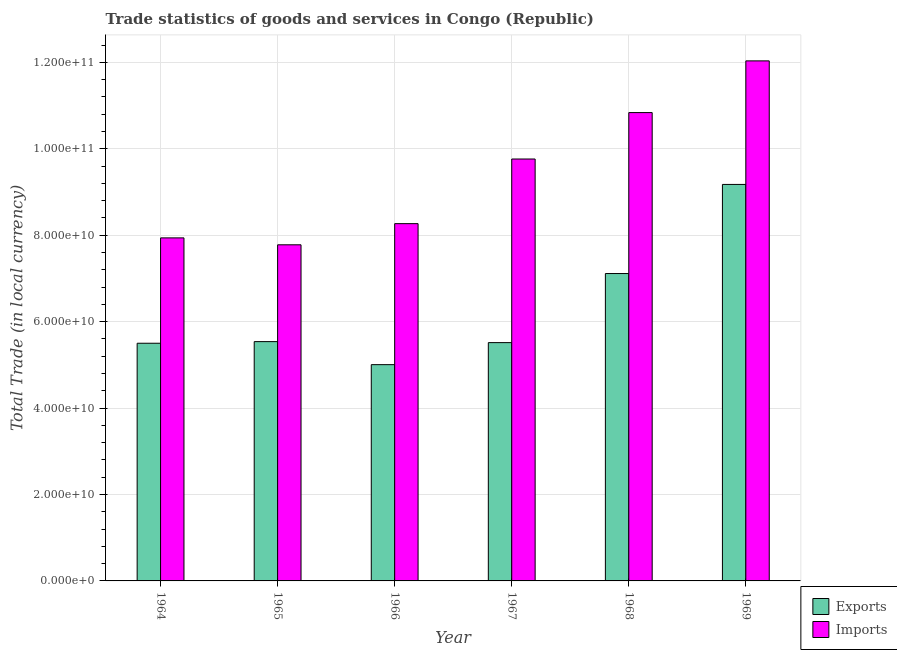How many different coloured bars are there?
Your answer should be compact. 2. Are the number of bars per tick equal to the number of legend labels?
Give a very brief answer. Yes. How many bars are there on the 5th tick from the left?
Your answer should be very brief. 2. What is the label of the 3rd group of bars from the left?
Your response must be concise. 1966. What is the export of goods and services in 1966?
Your answer should be very brief. 5.00e+1. Across all years, what is the maximum export of goods and services?
Your response must be concise. 9.18e+1. Across all years, what is the minimum export of goods and services?
Give a very brief answer. 5.00e+1. In which year was the imports of goods and services maximum?
Your response must be concise. 1969. In which year was the imports of goods and services minimum?
Offer a terse response. 1965. What is the total export of goods and services in the graph?
Keep it short and to the point. 3.78e+11. What is the difference between the imports of goods and services in 1964 and that in 1968?
Provide a succinct answer. -2.90e+1. What is the difference between the export of goods and services in 1966 and the imports of goods and services in 1965?
Keep it short and to the point. -5.33e+09. What is the average imports of goods and services per year?
Offer a terse response. 9.44e+1. In the year 1965, what is the difference between the imports of goods and services and export of goods and services?
Offer a very short reply. 0. What is the ratio of the imports of goods and services in 1966 to that in 1969?
Give a very brief answer. 0.69. Is the difference between the imports of goods and services in 1965 and 1967 greater than the difference between the export of goods and services in 1965 and 1967?
Make the answer very short. No. What is the difference between the highest and the second highest export of goods and services?
Offer a terse response. 2.06e+1. What is the difference between the highest and the lowest export of goods and services?
Keep it short and to the point. 4.17e+1. In how many years, is the export of goods and services greater than the average export of goods and services taken over all years?
Your answer should be very brief. 2. Is the sum of the export of goods and services in 1966 and 1969 greater than the maximum imports of goods and services across all years?
Offer a very short reply. Yes. What does the 2nd bar from the left in 1967 represents?
Make the answer very short. Imports. What does the 2nd bar from the right in 1969 represents?
Keep it short and to the point. Exports. How many years are there in the graph?
Offer a terse response. 6. What is the difference between two consecutive major ticks on the Y-axis?
Your answer should be very brief. 2.00e+1. Are the values on the major ticks of Y-axis written in scientific E-notation?
Ensure brevity in your answer.  Yes. Does the graph contain grids?
Offer a very short reply. Yes. Where does the legend appear in the graph?
Your response must be concise. Bottom right. How are the legend labels stacked?
Make the answer very short. Vertical. What is the title of the graph?
Ensure brevity in your answer.  Trade statistics of goods and services in Congo (Republic). What is the label or title of the Y-axis?
Your answer should be very brief. Total Trade (in local currency). What is the Total Trade (in local currency) in Exports in 1964?
Provide a succinct answer. 5.50e+1. What is the Total Trade (in local currency) of Imports in 1964?
Ensure brevity in your answer.  7.94e+1. What is the Total Trade (in local currency) of Exports in 1965?
Your answer should be compact. 5.54e+1. What is the Total Trade (in local currency) of Imports in 1965?
Offer a very short reply. 7.78e+1. What is the Total Trade (in local currency) in Exports in 1966?
Make the answer very short. 5.00e+1. What is the Total Trade (in local currency) in Imports in 1966?
Your answer should be compact. 8.27e+1. What is the Total Trade (in local currency) of Exports in 1967?
Offer a terse response. 5.51e+1. What is the Total Trade (in local currency) of Imports in 1967?
Provide a succinct answer. 9.76e+1. What is the Total Trade (in local currency) of Exports in 1968?
Ensure brevity in your answer.  7.11e+1. What is the Total Trade (in local currency) in Imports in 1968?
Make the answer very short. 1.08e+11. What is the Total Trade (in local currency) of Exports in 1969?
Your response must be concise. 9.18e+1. What is the Total Trade (in local currency) in Imports in 1969?
Offer a terse response. 1.20e+11. Across all years, what is the maximum Total Trade (in local currency) of Exports?
Your answer should be very brief. 9.18e+1. Across all years, what is the maximum Total Trade (in local currency) in Imports?
Make the answer very short. 1.20e+11. Across all years, what is the minimum Total Trade (in local currency) in Exports?
Provide a short and direct response. 5.00e+1. Across all years, what is the minimum Total Trade (in local currency) of Imports?
Provide a succinct answer. 7.78e+1. What is the total Total Trade (in local currency) in Exports in the graph?
Your answer should be very brief. 3.78e+11. What is the total Total Trade (in local currency) of Imports in the graph?
Ensure brevity in your answer.  5.66e+11. What is the difference between the Total Trade (in local currency) of Exports in 1964 and that in 1965?
Your answer should be compact. -3.75e+08. What is the difference between the Total Trade (in local currency) in Imports in 1964 and that in 1965?
Provide a short and direct response. 1.60e+09. What is the difference between the Total Trade (in local currency) in Exports in 1964 and that in 1966?
Ensure brevity in your answer.  4.95e+09. What is the difference between the Total Trade (in local currency) of Imports in 1964 and that in 1966?
Your answer should be very brief. -3.30e+09. What is the difference between the Total Trade (in local currency) in Exports in 1964 and that in 1967?
Provide a succinct answer. -1.44e+08. What is the difference between the Total Trade (in local currency) of Imports in 1964 and that in 1967?
Provide a succinct answer. -1.83e+1. What is the difference between the Total Trade (in local currency) in Exports in 1964 and that in 1968?
Provide a succinct answer. -1.61e+1. What is the difference between the Total Trade (in local currency) of Imports in 1964 and that in 1968?
Give a very brief answer. -2.90e+1. What is the difference between the Total Trade (in local currency) in Exports in 1964 and that in 1969?
Your answer should be compact. -3.68e+1. What is the difference between the Total Trade (in local currency) of Imports in 1964 and that in 1969?
Ensure brevity in your answer.  -4.10e+1. What is the difference between the Total Trade (in local currency) in Exports in 1965 and that in 1966?
Provide a short and direct response. 5.33e+09. What is the difference between the Total Trade (in local currency) in Imports in 1965 and that in 1966?
Your answer should be compact. -4.90e+09. What is the difference between the Total Trade (in local currency) of Exports in 1965 and that in 1967?
Your response must be concise. 2.32e+08. What is the difference between the Total Trade (in local currency) of Imports in 1965 and that in 1967?
Provide a short and direct response. -1.99e+1. What is the difference between the Total Trade (in local currency) in Exports in 1965 and that in 1968?
Your answer should be very brief. -1.58e+1. What is the difference between the Total Trade (in local currency) in Imports in 1965 and that in 1968?
Offer a terse response. -3.06e+1. What is the difference between the Total Trade (in local currency) of Exports in 1965 and that in 1969?
Offer a very short reply. -3.64e+1. What is the difference between the Total Trade (in local currency) of Imports in 1965 and that in 1969?
Give a very brief answer. -4.26e+1. What is the difference between the Total Trade (in local currency) in Exports in 1966 and that in 1967?
Keep it short and to the point. -5.10e+09. What is the difference between the Total Trade (in local currency) in Imports in 1966 and that in 1967?
Your answer should be very brief. -1.50e+1. What is the difference between the Total Trade (in local currency) in Exports in 1966 and that in 1968?
Give a very brief answer. -2.11e+1. What is the difference between the Total Trade (in local currency) of Imports in 1966 and that in 1968?
Ensure brevity in your answer.  -2.57e+1. What is the difference between the Total Trade (in local currency) of Exports in 1966 and that in 1969?
Make the answer very short. -4.17e+1. What is the difference between the Total Trade (in local currency) of Imports in 1966 and that in 1969?
Provide a short and direct response. -3.77e+1. What is the difference between the Total Trade (in local currency) of Exports in 1967 and that in 1968?
Ensure brevity in your answer.  -1.60e+1. What is the difference between the Total Trade (in local currency) in Imports in 1967 and that in 1968?
Offer a very short reply. -1.07e+1. What is the difference between the Total Trade (in local currency) in Exports in 1967 and that in 1969?
Offer a very short reply. -3.66e+1. What is the difference between the Total Trade (in local currency) of Imports in 1967 and that in 1969?
Your response must be concise. -2.27e+1. What is the difference between the Total Trade (in local currency) of Exports in 1968 and that in 1969?
Ensure brevity in your answer.  -2.06e+1. What is the difference between the Total Trade (in local currency) of Imports in 1968 and that in 1969?
Your answer should be very brief. -1.20e+1. What is the difference between the Total Trade (in local currency) of Exports in 1964 and the Total Trade (in local currency) of Imports in 1965?
Offer a very short reply. -2.28e+1. What is the difference between the Total Trade (in local currency) of Exports in 1964 and the Total Trade (in local currency) of Imports in 1966?
Your answer should be compact. -2.77e+1. What is the difference between the Total Trade (in local currency) in Exports in 1964 and the Total Trade (in local currency) in Imports in 1967?
Ensure brevity in your answer.  -4.26e+1. What is the difference between the Total Trade (in local currency) in Exports in 1964 and the Total Trade (in local currency) in Imports in 1968?
Your answer should be very brief. -5.34e+1. What is the difference between the Total Trade (in local currency) of Exports in 1964 and the Total Trade (in local currency) of Imports in 1969?
Give a very brief answer. -6.53e+1. What is the difference between the Total Trade (in local currency) of Exports in 1965 and the Total Trade (in local currency) of Imports in 1966?
Offer a very short reply. -2.73e+1. What is the difference between the Total Trade (in local currency) in Exports in 1965 and the Total Trade (in local currency) in Imports in 1967?
Your answer should be compact. -4.23e+1. What is the difference between the Total Trade (in local currency) of Exports in 1965 and the Total Trade (in local currency) of Imports in 1968?
Provide a short and direct response. -5.30e+1. What is the difference between the Total Trade (in local currency) of Exports in 1965 and the Total Trade (in local currency) of Imports in 1969?
Make the answer very short. -6.50e+1. What is the difference between the Total Trade (in local currency) in Exports in 1966 and the Total Trade (in local currency) in Imports in 1967?
Offer a very short reply. -4.76e+1. What is the difference between the Total Trade (in local currency) of Exports in 1966 and the Total Trade (in local currency) of Imports in 1968?
Provide a short and direct response. -5.83e+1. What is the difference between the Total Trade (in local currency) in Exports in 1966 and the Total Trade (in local currency) in Imports in 1969?
Give a very brief answer. -7.03e+1. What is the difference between the Total Trade (in local currency) in Exports in 1967 and the Total Trade (in local currency) in Imports in 1968?
Offer a terse response. -5.32e+1. What is the difference between the Total Trade (in local currency) in Exports in 1967 and the Total Trade (in local currency) in Imports in 1969?
Keep it short and to the point. -6.52e+1. What is the difference between the Total Trade (in local currency) in Exports in 1968 and the Total Trade (in local currency) in Imports in 1969?
Provide a succinct answer. -4.92e+1. What is the average Total Trade (in local currency) in Exports per year?
Make the answer very short. 6.31e+1. What is the average Total Trade (in local currency) of Imports per year?
Provide a succinct answer. 9.44e+1. In the year 1964, what is the difference between the Total Trade (in local currency) of Exports and Total Trade (in local currency) of Imports?
Make the answer very short. -2.44e+1. In the year 1965, what is the difference between the Total Trade (in local currency) of Exports and Total Trade (in local currency) of Imports?
Offer a terse response. -2.24e+1. In the year 1966, what is the difference between the Total Trade (in local currency) in Exports and Total Trade (in local currency) in Imports?
Your answer should be compact. -3.26e+1. In the year 1967, what is the difference between the Total Trade (in local currency) in Exports and Total Trade (in local currency) in Imports?
Your answer should be very brief. -4.25e+1. In the year 1968, what is the difference between the Total Trade (in local currency) in Exports and Total Trade (in local currency) in Imports?
Keep it short and to the point. -3.72e+1. In the year 1969, what is the difference between the Total Trade (in local currency) in Exports and Total Trade (in local currency) in Imports?
Keep it short and to the point. -2.86e+1. What is the ratio of the Total Trade (in local currency) of Imports in 1964 to that in 1965?
Make the answer very short. 1.02. What is the ratio of the Total Trade (in local currency) in Exports in 1964 to that in 1966?
Provide a short and direct response. 1.1. What is the ratio of the Total Trade (in local currency) in Imports in 1964 to that in 1966?
Keep it short and to the point. 0.96. What is the ratio of the Total Trade (in local currency) in Imports in 1964 to that in 1967?
Your response must be concise. 0.81. What is the ratio of the Total Trade (in local currency) in Exports in 1964 to that in 1968?
Your response must be concise. 0.77. What is the ratio of the Total Trade (in local currency) of Imports in 1964 to that in 1968?
Your answer should be compact. 0.73. What is the ratio of the Total Trade (in local currency) of Exports in 1964 to that in 1969?
Ensure brevity in your answer.  0.6. What is the ratio of the Total Trade (in local currency) of Imports in 1964 to that in 1969?
Ensure brevity in your answer.  0.66. What is the ratio of the Total Trade (in local currency) of Exports in 1965 to that in 1966?
Provide a succinct answer. 1.11. What is the ratio of the Total Trade (in local currency) in Imports in 1965 to that in 1966?
Ensure brevity in your answer.  0.94. What is the ratio of the Total Trade (in local currency) of Exports in 1965 to that in 1967?
Offer a terse response. 1. What is the ratio of the Total Trade (in local currency) of Imports in 1965 to that in 1967?
Provide a short and direct response. 0.8. What is the ratio of the Total Trade (in local currency) in Exports in 1965 to that in 1968?
Ensure brevity in your answer.  0.78. What is the ratio of the Total Trade (in local currency) of Imports in 1965 to that in 1968?
Make the answer very short. 0.72. What is the ratio of the Total Trade (in local currency) in Exports in 1965 to that in 1969?
Your response must be concise. 0.6. What is the ratio of the Total Trade (in local currency) in Imports in 1965 to that in 1969?
Provide a short and direct response. 0.65. What is the ratio of the Total Trade (in local currency) in Exports in 1966 to that in 1967?
Keep it short and to the point. 0.91. What is the ratio of the Total Trade (in local currency) in Imports in 1966 to that in 1967?
Ensure brevity in your answer.  0.85. What is the ratio of the Total Trade (in local currency) of Exports in 1966 to that in 1968?
Your answer should be very brief. 0.7. What is the ratio of the Total Trade (in local currency) of Imports in 1966 to that in 1968?
Provide a short and direct response. 0.76. What is the ratio of the Total Trade (in local currency) of Exports in 1966 to that in 1969?
Your answer should be compact. 0.55. What is the ratio of the Total Trade (in local currency) of Imports in 1966 to that in 1969?
Your answer should be very brief. 0.69. What is the ratio of the Total Trade (in local currency) in Exports in 1967 to that in 1968?
Your response must be concise. 0.78. What is the ratio of the Total Trade (in local currency) in Imports in 1967 to that in 1968?
Provide a succinct answer. 0.9. What is the ratio of the Total Trade (in local currency) in Exports in 1967 to that in 1969?
Your answer should be very brief. 0.6. What is the ratio of the Total Trade (in local currency) of Imports in 1967 to that in 1969?
Provide a short and direct response. 0.81. What is the ratio of the Total Trade (in local currency) of Exports in 1968 to that in 1969?
Your response must be concise. 0.78. What is the ratio of the Total Trade (in local currency) in Imports in 1968 to that in 1969?
Provide a succinct answer. 0.9. What is the difference between the highest and the second highest Total Trade (in local currency) in Exports?
Offer a terse response. 2.06e+1. What is the difference between the highest and the second highest Total Trade (in local currency) of Imports?
Provide a short and direct response. 1.20e+1. What is the difference between the highest and the lowest Total Trade (in local currency) in Exports?
Keep it short and to the point. 4.17e+1. What is the difference between the highest and the lowest Total Trade (in local currency) in Imports?
Offer a very short reply. 4.26e+1. 